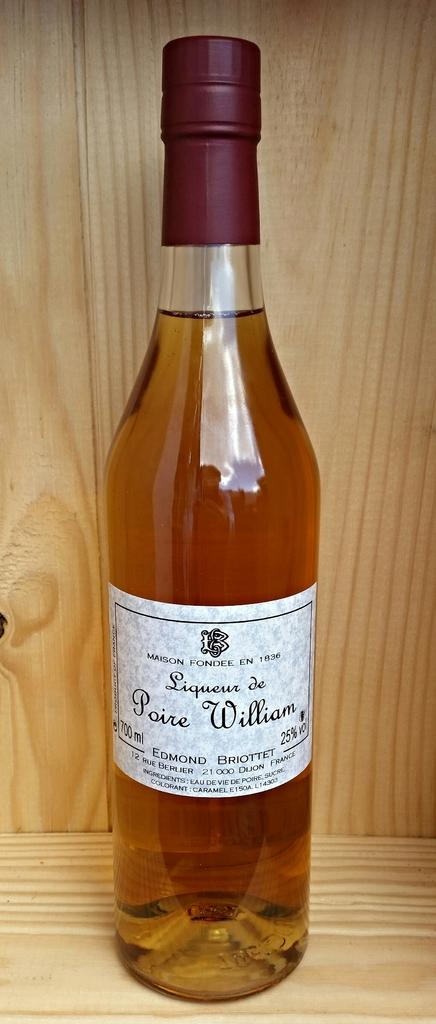What object can be seen in the image? There is a bottle in the image. What type of arch can be seen in the image? There is no arch present in the image; it only features a bottle. How many hands are visible in the image? There are no hands visible in the image; it only features a bottle. 